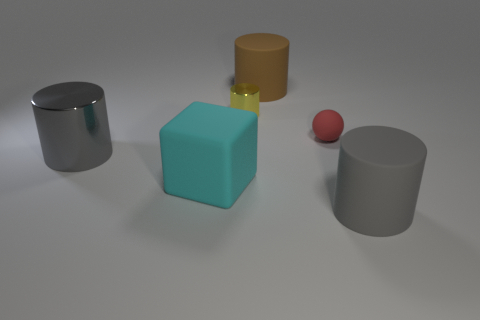There is a object that is to the left of the cyan thing; is it the same shape as the thing right of the red object?
Provide a succinct answer. Yes. Is the number of big gray metallic objects on the left side of the red rubber sphere less than the number of things left of the small yellow metal thing?
Offer a terse response. Yes. What number of other objects are there of the same shape as the small yellow object?
Ensure brevity in your answer.  3. What is the shape of the brown object that is the same material as the small red sphere?
Offer a terse response. Cylinder. There is a cylinder that is both on the right side of the yellow object and in front of the small metal cylinder; what is its color?
Your answer should be compact. Gray. Is the large gray cylinder in front of the large gray metallic cylinder made of the same material as the tiny cylinder?
Give a very brief answer. No. Are there fewer brown cylinders on the right side of the tiny matte thing than gray shiny spheres?
Ensure brevity in your answer.  No. Is there a tiny red thing made of the same material as the large brown cylinder?
Your answer should be compact. Yes. There is a yellow shiny cylinder; does it have the same size as the sphere behind the large cyan rubber cube?
Your answer should be compact. Yes. Is there a rubber object of the same color as the large metallic thing?
Your response must be concise. Yes. 